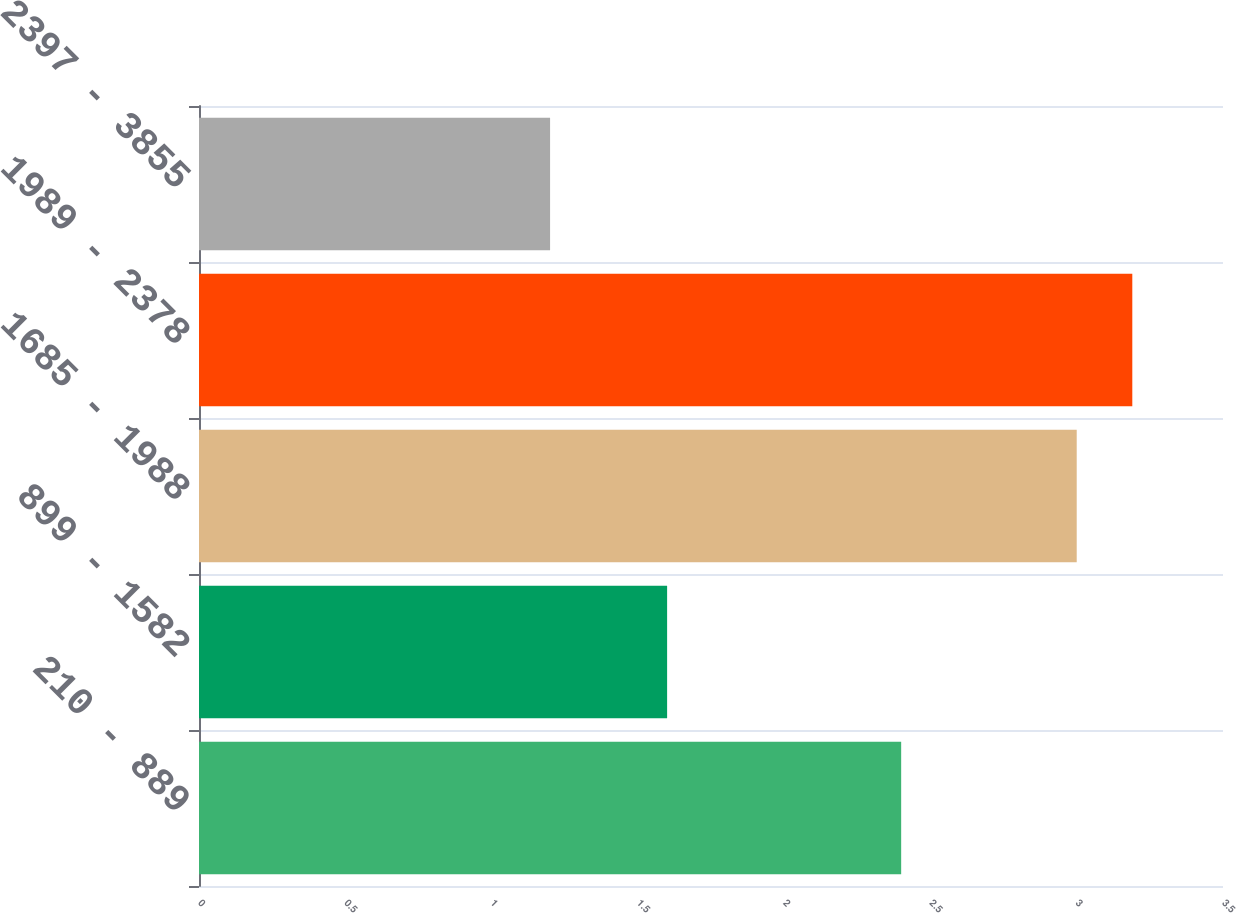<chart> <loc_0><loc_0><loc_500><loc_500><bar_chart><fcel>210 - 889<fcel>899 - 1582<fcel>1685 - 1988<fcel>1989 - 2378<fcel>2397 - 3855<nl><fcel>2.4<fcel>1.6<fcel>3<fcel>3.19<fcel>1.2<nl></chart> 